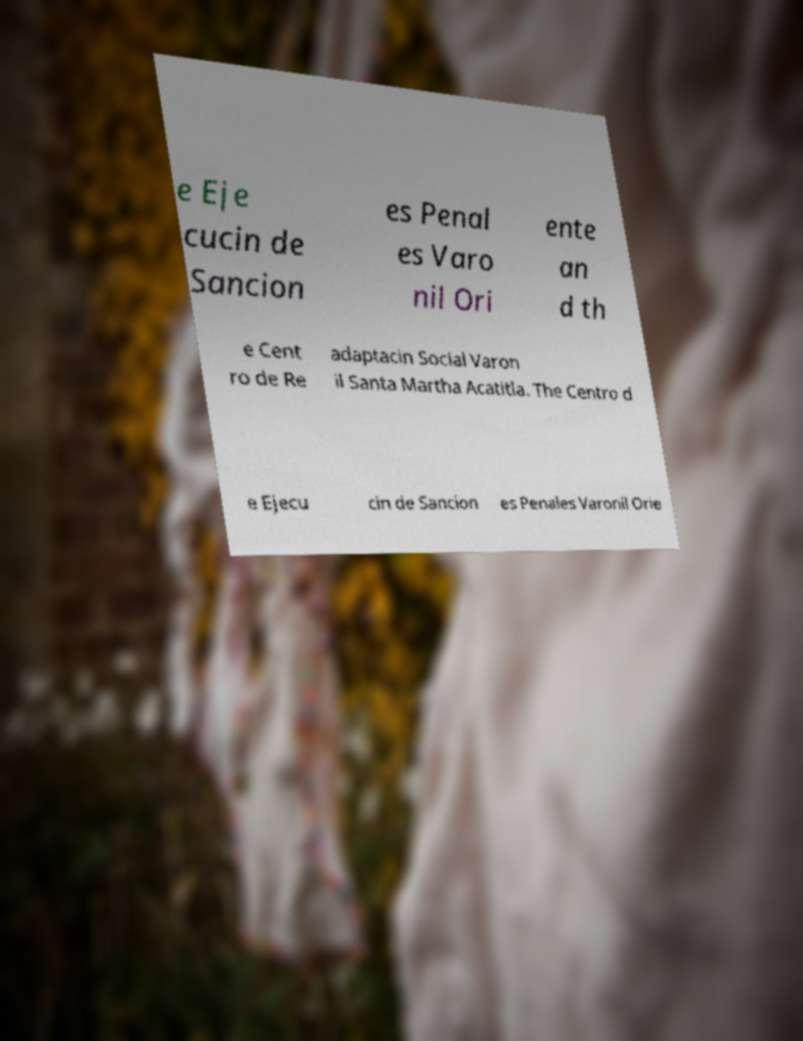Could you extract and type out the text from this image? e Eje cucin de Sancion es Penal es Varo nil Ori ente an d th e Cent ro de Re adaptacin Social Varon il Santa Martha Acatitla. The Centro d e Ejecu cin de Sancion es Penales Varonil Orie 